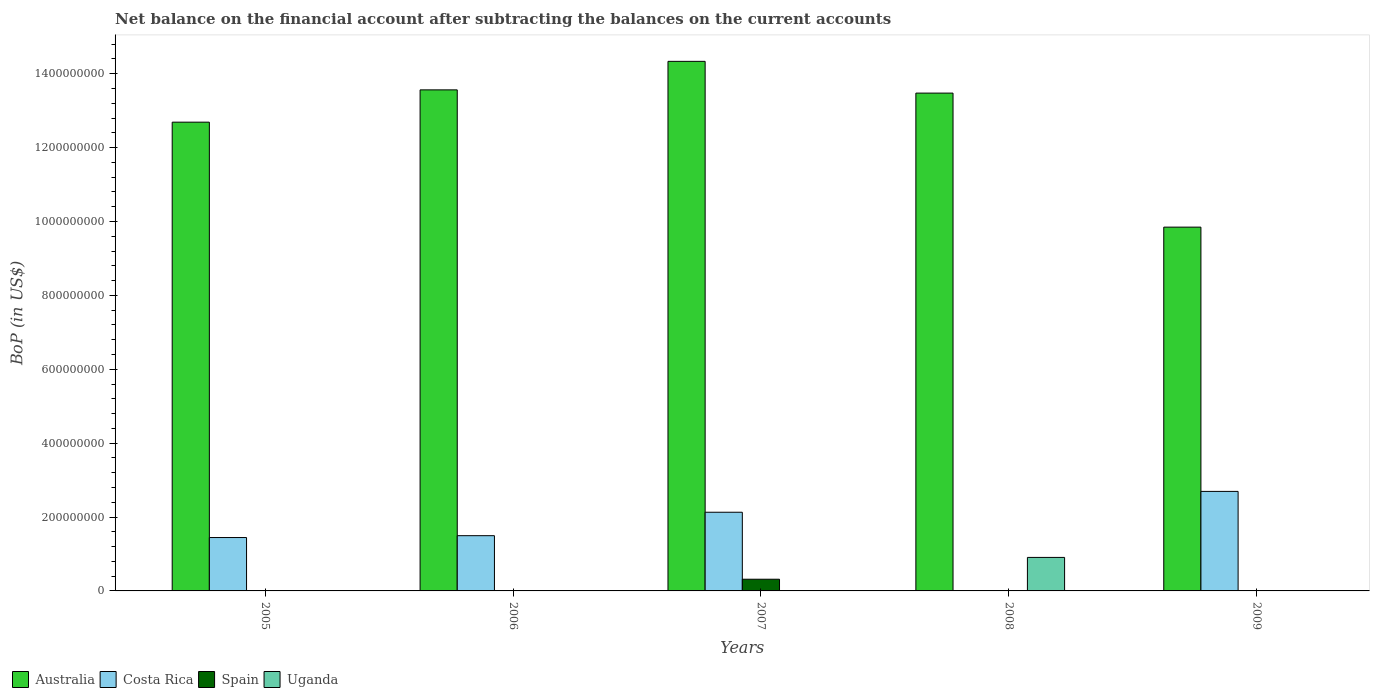How many different coloured bars are there?
Provide a succinct answer. 4. Are the number of bars on each tick of the X-axis equal?
Your response must be concise. No. How many bars are there on the 1st tick from the left?
Your answer should be compact. 2. How many bars are there on the 2nd tick from the right?
Offer a very short reply. 2. What is the Balance of Payments in Spain in 2008?
Your answer should be very brief. 0. Across all years, what is the maximum Balance of Payments in Uganda?
Give a very brief answer. 9.07e+07. Across all years, what is the minimum Balance of Payments in Spain?
Ensure brevity in your answer.  0. In which year was the Balance of Payments in Uganda maximum?
Your response must be concise. 2008. What is the total Balance of Payments in Australia in the graph?
Make the answer very short. 6.39e+09. What is the difference between the Balance of Payments in Australia in 2006 and that in 2007?
Offer a terse response. -7.72e+07. What is the difference between the Balance of Payments in Costa Rica in 2005 and the Balance of Payments in Uganda in 2009?
Provide a succinct answer. 1.44e+08. What is the average Balance of Payments in Australia per year?
Make the answer very short. 1.28e+09. In the year 2008, what is the difference between the Balance of Payments in Uganda and Balance of Payments in Australia?
Make the answer very short. -1.26e+09. In how many years, is the Balance of Payments in Costa Rica greater than 960000000 US$?
Your answer should be very brief. 0. What is the ratio of the Balance of Payments in Costa Rica in 2005 to that in 2009?
Provide a succinct answer. 0.54. Is the Balance of Payments in Costa Rica in 2006 less than that in 2007?
Give a very brief answer. Yes. What is the difference between the highest and the second highest Balance of Payments in Costa Rica?
Provide a short and direct response. 5.64e+07. What is the difference between the highest and the lowest Balance of Payments in Spain?
Provide a succinct answer. 3.16e+07. In how many years, is the Balance of Payments in Costa Rica greater than the average Balance of Payments in Costa Rica taken over all years?
Your response must be concise. 2. Is the sum of the Balance of Payments in Australia in 2007 and 2008 greater than the maximum Balance of Payments in Uganda across all years?
Your answer should be very brief. Yes. Is it the case that in every year, the sum of the Balance of Payments in Uganda and Balance of Payments in Costa Rica is greater than the Balance of Payments in Australia?
Ensure brevity in your answer.  No. How many bars are there?
Offer a very short reply. 11. Are all the bars in the graph horizontal?
Your answer should be very brief. No. How many years are there in the graph?
Your response must be concise. 5. What is the difference between two consecutive major ticks on the Y-axis?
Your answer should be very brief. 2.00e+08. Are the values on the major ticks of Y-axis written in scientific E-notation?
Ensure brevity in your answer.  No. Does the graph contain any zero values?
Keep it short and to the point. Yes. How many legend labels are there?
Provide a short and direct response. 4. What is the title of the graph?
Your answer should be compact. Net balance on the financial account after subtracting the balances on the current accounts. Does "Cabo Verde" appear as one of the legend labels in the graph?
Make the answer very short. No. What is the label or title of the Y-axis?
Provide a short and direct response. BoP (in US$). What is the BoP (in US$) of Australia in 2005?
Give a very brief answer. 1.27e+09. What is the BoP (in US$) in Costa Rica in 2005?
Your answer should be compact. 1.44e+08. What is the BoP (in US$) in Spain in 2005?
Provide a short and direct response. 0. What is the BoP (in US$) in Uganda in 2005?
Offer a very short reply. 0. What is the BoP (in US$) in Australia in 2006?
Offer a very short reply. 1.36e+09. What is the BoP (in US$) of Costa Rica in 2006?
Give a very brief answer. 1.50e+08. What is the BoP (in US$) in Spain in 2006?
Your response must be concise. 0. What is the BoP (in US$) in Australia in 2007?
Your answer should be very brief. 1.43e+09. What is the BoP (in US$) in Costa Rica in 2007?
Offer a very short reply. 2.13e+08. What is the BoP (in US$) in Spain in 2007?
Ensure brevity in your answer.  3.16e+07. What is the BoP (in US$) of Uganda in 2007?
Give a very brief answer. 0. What is the BoP (in US$) in Australia in 2008?
Provide a succinct answer. 1.35e+09. What is the BoP (in US$) in Uganda in 2008?
Provide a short and direct response. 9.07e+07. What is the BoP (in US$) in Australia in 2009?
Make the answer very short. 9.85e+08. What is the BoP (in US$) in Costa Rica in 2009?
Offer a terse response. 2.69e+08. Across all years, what is the maximum BoP (in US$) in Australia?
Offer a very short reply. 1.43e+09. Across all years, what is the maximum BoP (in US$) of Costa Rica?
Make the answer very short. 2.69e+08. Across all years, what is the maximum BoP (in US$) in Spain?
Keep it short and to the point. 3.16e+07. Across all years, what is the maximum BoP (in US$) in Uganda?
Provide a succinct answer. 9.07e+07. Across all years, what is the minimum BoP (in US$) of Australia?
Offer a terse response. 9.85e+08. What is the total BoP (in US$) in Australia in the graph?
Your response must be concise. 6.39e+09. What is the total BoP (in US$) in Costa Rica in the graph?
Your answer should be very brief. 7.76e+08. What is the total BoP (in US$) in Spain in the graph?
Your response must be concise. 3.16e+07. What is the total BoP (in US$) of Uganda in the graph?
Ensure brevity in your answer.  9.07e+07. What is the difference between the BoP (in US$) in Australia in 2005 and that in 2006?
Ensure brevity in your answer.  -8.74e+07. What is the difference between the BoP (in US$) in Costa Rica in 2005 and that in 2006?
Give a very brief answer. -5.05e+06. What is the difference between the BoP (in US$) of Australia in 2005 and that in 2007?
Your answer should be compact. -1.65e+08. What is the difference between the BoP (in US$) in Costa Rica in 2005 and that in 2007?
Give a very brief answer. -6.85e+07. What is the difference between the BoP (in US$) in Australia in 2005 and that in 2008?
Provide a succinct answer. -7.86e+07. What is the difference between the BoP (in US$) of Australia in 2005 and that in 2009?
Your answer should be very brief. 2.84e+08. What is the difference between the BoP (in US$) in Costa Rica in 2005 and that in 2009?
Offer a terse response. -1.25e+08. What is the difference between the BoP (in US$) in Australia in 2006 and that in 2007?
Provide a short and direct response. -7.72e+07. What is the difference between the BoP (in US$) in Costa Rica in 2006 and that in 2007?
Your answer should be very brief. -6.34e+07. What is the difference between the BoP (in US$) of Australia in 2006 and that in 2008?
Give a very brief answer. 8.75e+06. What is the difference between the BoP (in US$) in Australia in 2006 and that in 2009?
Offer a very short reply. 3.72e+08. What is the difference between the BoP (in US$) of Costa Rica in 2006 and that in 2009?
Provide a succinct answer. -1.20e+08. What is the difference between the BoP (in US$) in Australia in 2007 and that in 2008?
Offer a terse response. 8.59e+07. What is the difference between the BoP (in US$) of Australia in 2007 and that in 2009?
Your answer should be very brief. 4.49e+08. What is the difference between the BoP (in US$) of Costa Rica in 2007 and that in 2009?
Give a very brief answer. -5.64e+07. What is the difference between the BoP (in US$) in Australia in 2008 and that in 2009?
Keep it short and to the point. 3.63e+08. What is the difference between the BoP (in US$) in Australia in 2005 and the BoP (in US$) in Costa Rica in 2006?
Give a very brief answer. 1.12e+09. What is the difference between the BoP (in US$) of Australia in 2005 and the BoP (in US$) of Costa Rica in 2007?
Ensure brevity in your answer.  1.06e+09. What is the difference between the BoP (in US$) in Australia in 2005 and the BoP (in US$) in Spain in 2007?
Your response must be concise. 1.24e+09. What is the difference between the BoP (in US$) in Costa Rica in 2005 and the BoP (in US$) in Spain in 2007?
Offer a terse response. 1.13e+08. What is the difference between the BoP (in US$) of Australia in 2005 and the BoP (in US$) of Uganda in 2008?
Your response must be concise. 1.18e+09. What is the difference between the BoP (in US$) in Costa Rica in 2005 and the BoP (in US$) in Uganda in 2008?
Provide a succinct answer. 5.38e+07. What is the difference between the BoP (in US$) in Australia in 2005 and the BoP (in US$) in Costa Rica in 2009?
Offer a very short reply. 9.99e+08. What is the difference between the BoP (in US$) in Australia in 2006 and the BoP (in US$) in Costa Rica in 2007?
Ensure brevity in your answer.  1.14e+09. What is the difference between the BoP (in US$) of Australia in 2006 and the BoP (in US$) of Spain in 2007?
Ensure brevity in your answer.  1.32e+09. What is the difference between the BoP (in US$) in Costa Rica in 2006 and the BoP (in US$) in Spain in 2007?
Provide a succinct answer. 1.18e+08. What is the difference between the BoP (in US$) of Australia in 2006 and the BoP (in US$) of Uganda in 2008?
Your answer should be compact. 1.27e+09. What is the difference between the BoP (in US$) in Costa Rica in 2006 and the BoP (in US$) in Uganda in 2008?
Ensure brevity in your answer.  5.88e+07. What is the difference between the BoP (in US$) of Australia in 2006 and the BoP (in US$) of Costa Rica in 2009?
Provide a succinct answer. 1.09e+09. What is the difference between the BoP (in US$) in Australia in 2007 and the BoP (in US$) in Uganda in 2008?
Provide a short and direct response. 1.34e+09. What is the difference between the BoP (in US$) in Costa Rica in 2007 and the BoP (in US$) in Uganda in 2008?
Keep it short and to the point. 1.22e+08. What is the difference between the BoP (in US$) in Spain in 2007 and the BoP (in US$) in Uganda in 2008?
Offer a very short reply. -5.90e+07. What is the difference between the BoP (in US$) in Australia in 2007 and the BoP (in US$) in Costa Rica in 2009?
Provide a short and direct response. 1.16e+09. What is the difference between the BoP (in US$) in Australia in 2008 and the BoP (in US$) in Costa Rica in 2009?
Your answer should be very brief. 1.08e+09. What is the average BoP (in US$) of Australia per year?
Provide a succinct answer. 1.28e+09. What is the average BoP (in US$) of Costa Rica per year?
Offer a terse response. 1.55e+08. What is the average BoP (in US$) of Spain per year?
Keep it short and to the point. 6.33e+06. What is the average BoP (in US$) in Uganda per year?
Your answer should be compact. 1.81e+07. In the year 2005, what is the difference between the BoP (in US$) of Australia and BoP (in US$) of Costa Rica?
Provide a succinct answer. 1.12e+09. In the year 2006, what is the difference between the BoP (in US$) of Australia and BoP (in US$) of Costa Rica?
Your answer should be very brief. 1.21e+09. In the year 2007, what is the difference between the BoP (in US$) of Australia and BoP (in US$) of Costa Rica?
Your response must be concise. 1.22e+09. In the year 2007, what is the difference between the BoP (in US$) of Australia and BoP (in US$) of Spain?
Keep it short and to the point. 1.40e+09. In the year 2007, what is the difference between the BoP (in US$) of Costa Rica and BoP (in US$) of Spain?
Offer a terse response. 1.81e+08. In the year 2008, what is the difference between the BoP (in US$) in Australia and BoP (in US$) in Uganda?
Provide a short and direct response. 1.26e+09. In the year 2009, what is the difference between the BoP (in US$) of Australia and BoP (in US$) of Costa Rica?
Give a very brief answer. 7.15e+08. What is the ratio of the BoP (in US$) in Australia in 2005 to that in 2006?
Keep it short and to the point. 0.94. What is the ratio of the BoP (in US$) of Costa Rica in 2005 to that in 2006?
Offer a very short reply. 0.97. What is the ratio of the BoP (in US$) of Australia in 2005 to that in 2007?
Provide a succinct answer. 0.89. What is the ratio of the BoP (in US$) in Costa Rica in 2005 to that in 2007?
Ensure brevity in your answer.  0.68. What is the ratio of the BoP (in US$) in Australia in 2005 to that in 2008?
Provide a succinct answer. 0.94. What is the ratio of the BoP (in US$) of Australia in 2005 to that in 2009?
Your answer should be very brief. 1.29. What is the ratio of the BoP (in US$) of Costa Rica in 2005 to that in 2009?
Make the answer very short. 0.54. What is the ratio of the BoP (in US$) in Australia in 2006 to that in 2007?
Offer a terse response. 0.95. What is the ratio of the BoP (in US$) in Costa Rica in 2006 to that in 2007?
Ensure brevity in your answer.  0.7. What is the ratio of the BoP (in US$) in Australia in 2006 to that in 2008?
Your answer should be compact. 1.01. What is the ratio of the BoP (in US$) of Australia in 2006 to that in 2009?
Your response must be concise. 1.38. What is the ratio of the BoP (in US$) of Costa Rica in 2006 to that in 2009?
Your answer should be compact. 0.56. What is the ratio of the BoP (in US$) of Australia in 2007 to that in 2008?
Keep it short and to the point. 1.06. What is the ratio of the BoP (in US$) in Australia in 2007 to that in 2009?
Offer a terse response. 1.46. What is the ratio of the BoP (in US$) in Costa Rica in 2007 to that in 2009?
Give a very brief answer. 0.79. What is the ratio of the BoP (in US$) in Australia in 2008 to that in 2009?
Your answer should be very brief. 1.37. What is the difference between the highest and the second highest BoP (in US$) of Australia?
Ensure brevity in your answer.  7.72e+07. What is the difference between the highest and the second highest BoP (in US$) of Costa Rica?
Give a very brief answer. 5.64e+07. What is the difference between the highest and the lowest BoP (in US$) in Australia?
Offer a very short reply. 4.49e+08. What is the difference between the highest and the lowest BoP (in US$) of Costa Rica?
Your answer should be very brief. 2.69e+08. What is the difference between the highest and the lowest BoP (in US$) in Spain?
Your answer should be compact. 3.16e+07. What is the difference between the highest and the lowest BoP (in US$) of Uganda?
Offer a very short reply. 9.07e+07. 